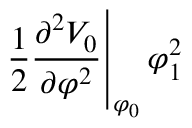<formula> <loc_0><loc_0><loc_500><loc_500>\frac { 1 } { 2 } \frac { \partial ^ { 2 } V _ { 0 } } { \partial \varphi ^ { 2 } } \right | _ { \varphi _ { 0 } } \varphi _ { 1 } ^ { 2 }</formula> 